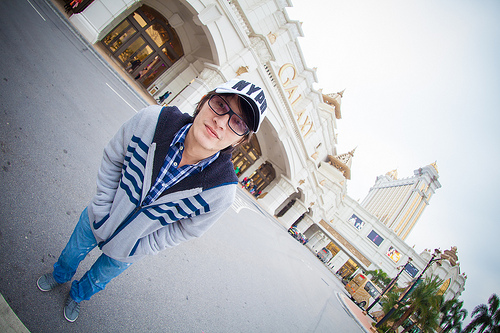<image>
Is the human on the road? Yes. Looking at the image, I can see the human is positioned on top of the road, with the road providing support. 